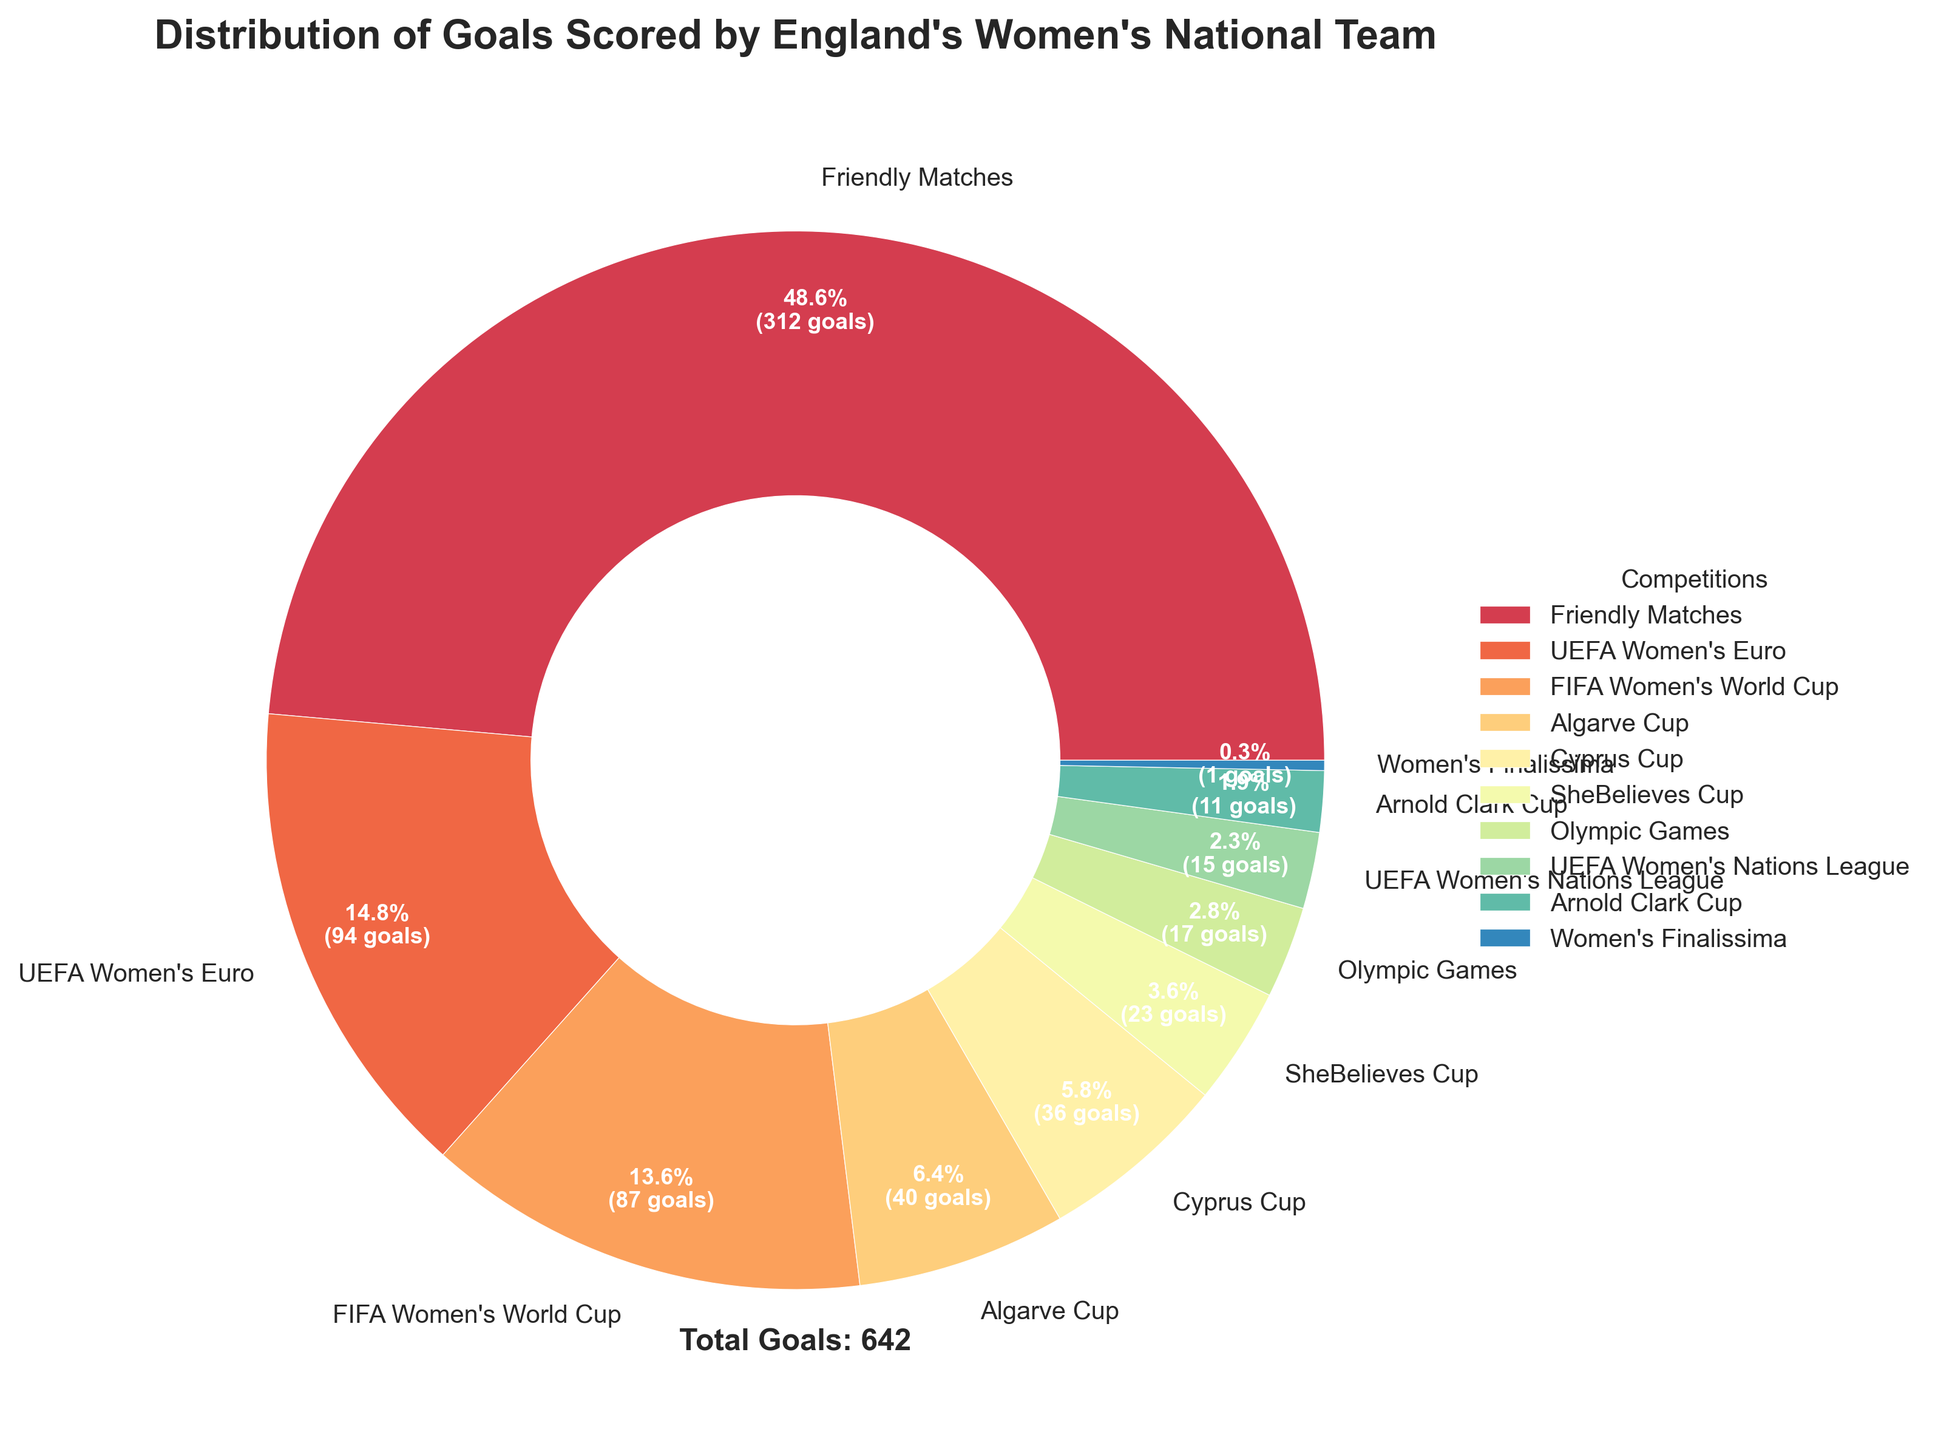Which competition has the highest percentage of goals scored by England's women's national team? By looking at the pie chart, identify the segment with the largest area and its label.
Answer: Friendly Matches How many goals did England's women's national team score in the UEFA Women's Euro and FIFA Women's World Cup combined? Sum the goals scored in the UEFA Women's Euro (95) and FIFA Women's World Cup (87).
Answer: 182 Which two competitions have the smallest shares in the pie chart? Identify the labels corresponding to the two smallest segments in the pie chart.
Answer: Women's Finalissima and Arnold Clark Cup How does the number of goals in Friendly Matches compare to the Algarve Cup and Cyprus Cup combined? Compare the goal count of Friendly Matches (312) with the sum of goals in the Algarve Cup (41) and Cyprus Cup (37).
Answer: Friendly Matches have more goals What percentage of goals were scored in SheBelieves Cup and Olympic Games together? Sum the goals of SheBelieves Cup (23) and Olympic Games (18), then calculate the percentage out of the total goals (632).
Answer: Approximately 6.5% What's the difference in the number of goals scored between the competition with the highest and the one with the lowest goals? Subtract the goals scored in the Women's Finalissima (2) from those in Friendly Matches (312).
Answer: 310 How many more goals were scored in the UEFA Women's Euro compared to the UEFA Women's Nations League? Subtract the goals in the UEFA Women's Nations League (15) from those in the UEFA Women's Euro (95).
Answer: 80 Which competition scored just a little more than double the goals of the Arnold Clark Cup? Identify the competition with a goal count a little more than twice the Arnold Clark Cup's (12) goals.
Answer: Cyprus Cup 